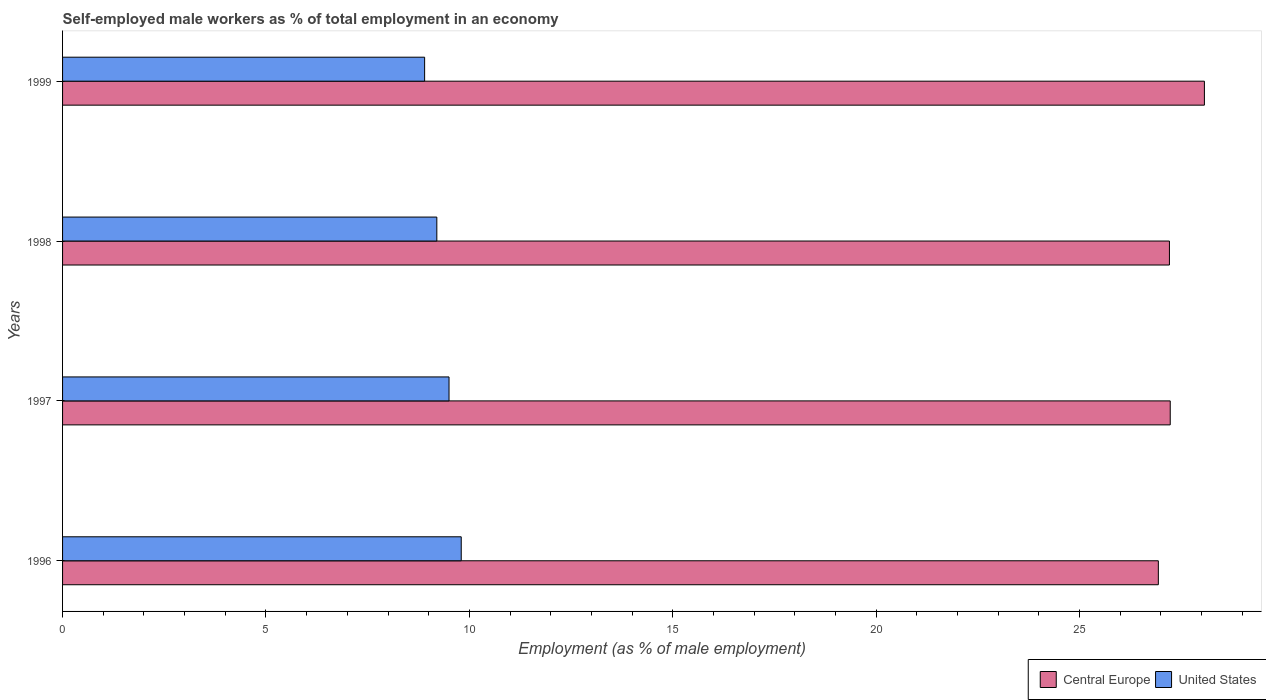Are the number of bars on each tick of the Y-axis equal?
Make the answer very short. Yes. How many bars are there on the 3rd tick from the top?
Give a very brief answer. 2. In how many cases, is the number of bars for a given year not equal to the number of legend labels?
Ensure brevity in your answer.  0. What is the percentage of self-employed male workers in Central Europe in 1996?
Make the answer very short. 26.94. Across all years, what is the maximum percentage of self-employed male workers in United States?
Your answer should be very brief. 9.8. Across all years, what is the minimum percentage of self-employed male workers in Central Europe?
Ensure brevity in your answer.  26.94. In which year was the percentage of self-employed male workers in United States minimum?
Your answer should be very brief. 1999. What is the total percentage of self-employed male workers in United States in the graph?
Provide a short and direct response. 37.4. What is the difference between the percentage of self-employed male workers in Central Europe in 1996 and that in 1999?
Make the answer very short. -1.13. What is the difference between the percentage of self-employed male workers in Central Europe in 1998 and the percentage of self-employed male workers in United States in 1997?
Provide a succinct answer. 17.71. What is the average percentage of self-employed male workers in United States per year?
Provide a short and direct response. 9.35. In the year 1999, what is the difference between the percentage of self-employed male workers in Central Europe and percentage of self-employed male workers in United States?
Offer a terse response. 19.17. What is the ratio of the percentage of self-employed male workers in United States in 1997 to that in 1999?
Keep it short and to the point. 1.07. What is the difference between the highest and the second highest percentage of self-employed male workers in United States?
Ensure brevity in your answer.  0.3. What is the difference between the highest and the lowest percentage of self-employed male workers in United States?
Your answer should be very brief. 0.9. In how many years, is the percentage of self-employed male workers in United States greater than the average percentage of self-employed male workers in United States taken over all years?
Your response must be concise. 2. What does the 1st bar from the top in 1998 represents?
Provide a succinct answer. United States. What does the 1st bar from the bottom in 1999 represents?
Your answer should be compact. Central Europe. How many bars are there?
Your response must be concise. 8. How many years are there in the graph?
Keep it short and to the point. 4. What is the difference between two consecutive major ticks on the X-axis?
Your answer should be very brief. 5. Does the graph contain any zero values?
Ensure brevity in your answer.  No. Does the graph contain grids?
Offer a terse response. No. Where does the legend appear in the graph?
Your answer should be compact. Bottom right. What is the title of the graph?
Provide a succinct answer. Self-employed male workers as % of total employment in an economy. What is the label or title of the X-axis?
Provide a short and direct response. Employment (as % of male employment). What is the Employment (as % of male employment) in Central Europe in 1996?
Keep it short and to the point. 26.94. What is the Employment (as % of male employment) of United States in 1996?
Your answer should be very brief. 9.8. What is the Employment (as % of male employment) of Central Europe in 1997?
Make the answer very short. 27.23. What is the Employment (as % of male employment) of United States in 1997?
Ensure brevity in your answer.  9.5. What is the Employment (as % of male employment) in Central Europe in 1998?
Offer a terse response. 27.21. What is the Employment (as % of male employment) in United States in 1998?
Offer a very short reply. 9.2. What is the Employment (as % of male employment) of Central Europe in 1999?
Make the answer very short. 28.07. What is the Employment (as % of male employment) of United States in 1999?
Keep it short and to the point. 8.9. Across all years, what is the maximum Employment (as % of male employment) in Central Europe?
Offer a very short reply. 28.07. Across all years, what is the maximum Employment (as % of male employment) of United States?
Provide a succinct answer. 9.8. Across all years, what is the minimum Employment (as % of male employment) in Central Europe?
Make the answer very short. 26.94. Across all years, what is the minimum Employment (as % of male employment) in United States?
Provide a succinct answer. 8.9. What is the total Employment (as % of male employment) of Central Europe in the graph?
Provide a succinct answer. 109.44. What is the total Employment (as % of male employment) in United States in the graph?
Your answer should be compact. 37.4. What is the difference between the Employment (as % of male employment) in Central Europe in 1996 and that in 1997?
Give a very brief answer. -0.29. What is the difference between the Employment (as % of male employment) in United States in 1996 and that in 1997?
Keep it short and to the point. 0.3. What is the difference between the Employment (as % of male employment) in Central Europe in 1996 and that in 1998?
Your answer should be very brief. -0.27. What is the difference between the Employment (as % of male employment) in Central Europe in 1996 and that in 1999?
Offer a terse response. -1.13. What is the difference between the Employment (as % of male employment) in United States in 1996 and that in 1999?
Give a very brief answer. 0.9. What is the difference between the Employment (as % of male employment) of Central Europe in 1997 and that in 1998?
Offer a very short reply. 0.02. What is the difference between the Employment (as % of male employment) of Central Europe in 1997 and that in 1999?
Provide a succinct answer. -0.84. What is the difference between the Employment (as % of male employment) in United States in 1997 and that in 1999?
Offer a terse response. 0.6. What is the difference between the Employment (as % of male employment) in Central Europe in 1998 and that in 1999?
Keep it short and to the point. -0.86. What is the difference between the Employment (as % of male employment) in Central Europe in 1996 and the Employment (as % of male employment) in United States in 1997?
Offer a terse response. 17.44. What is the difference between the Employment (as % of male employment) of Central Europe in 1996 and the Employment (as % of male employment) of United States in 1998?
Ensure brevity in your answer.  17.74. What is the difference between the Employment (as % of male employment) in Central Europe in 1996 and the Employment (as % of male employment) in United States in 1999?
Make the answer very short. 18.04. What is the difference between the Employment (as % of male employment) of Central Europe in 1997 and the Employment (as % of male employment) of United States in 1998?
Give a very brief answer. 18.03. What is the difference between the Employment (as % of male employment) of Central Europe in 1997 and the Employment (as % of male employment) of United States in 1999?
Your answer should be compact. 18.33. What is the difference between the Employment (as % of male employment) of Central Europe in 1998 and the Employment (as % of male employment) of United States in 1999?
Your answer should be very brief. 18.31. What is the average Employment (as % of male employment) in Central Europe per year?
Ensure brevity in your answer.  27.36. What is the average Employment (as % of male employment) of United States per year?
Give a very brief answer. 9.35. In the year 1996, what is the difference between the Employment (as % of male employment) of Central Europe and Employment (as % of male employment) of United States?
Offer a terse response. 17.14. In the year 1997, what is the difference between the Employment (as % of male employment) in Central Europe and Employment (as % of male employment) in United States?
Offer a terse response. 17.73. In the year 1998, what is the difference between the Employment (as % of male employment) in Central Europe and Employment (as % of male employment) in United States?
Ensure brevity in your answer.  18.01. In the year 1999, what is the difference between the Employment (as % of male employment) in Central Europe and Employment (as % of male employment) in United States?
Make the answer very short. 19.17. What is the ratio of the Employment (as % of male employment) in Central Europe in 1996 to that in 1997?
Make the answer very short. 0.99. What is the ratio of the Employment (as % of male employment) in United States in 1996 to that in 1997?
Ensure brevity in your answer.  1.03. What is the ratio of the Employment (as % of male employment) in Central Europe in 1996 to that in 1998?
Your response must be concise. 0.99. What is the ratio of the Employment (as % of male employment) in United States in 1996 to that in 1998?
Offer a terse response. 1.07. What is the ratio of the Employment (as % of male employment) in Central Europe in 1996 to that in 1999?
Your response must be concise. 0.96. What is the ratio of the Employment (as % of male employment) of United States in 1996 to that in 1999?
Offer a very short reply. 1.1. What is the ratio of the Employment (as % of male employment) in United States in 1997 to that in 1998?
Ensure brevity in your answer.  1.03. What is the ratio of the Employment (as % of male employment) of Central Europe in 1997 to that in 1999?
Give a very brief answer. 0.97. What is the ratio of the Employment (as % of male employment) in United States in 1997 to that in 1999?
Make the answer very short. 1.07. What is the ratio of the Employment (as % of male employment) in Central Europe in 1998 to that in 1999?
Keep it short and to the point. 0.97. What is the ratio of the Employment (as % of male employment) of United States in 1998 to that in 1999?
Provide a succinct answer. 1.03. What is the difference between the highest and the second highest Employment (as % of male employment) of Central Europe?
Give a very brief answer. 0.84. What is the difference between the highest and the second highest Employment (as % of male employment) in United States?
Provide a succinct answer. 0.3. What is the difference between the highest and the lowest Employment (as % of male employment) of Central Europe?
Offer a very short reply. 1.13. What is the difference between the highest and the lowest Employment (as % of male employment) in United States?
Your answer should be compact. 0.9. 